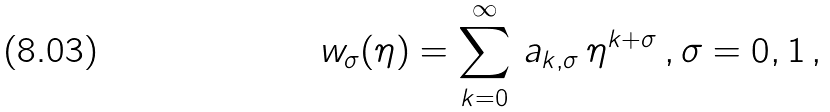<formula> <loc_0><loc_0><loc_500><loc_500>w _ { \sigma } ( \eta ) = \sum _ { k = 0 } ^ { \infty } \, a _ { k , \sigma } \, \eta ^ { k + \sigma } \, , \sigma = 0 , 1 \, ,</formula> 